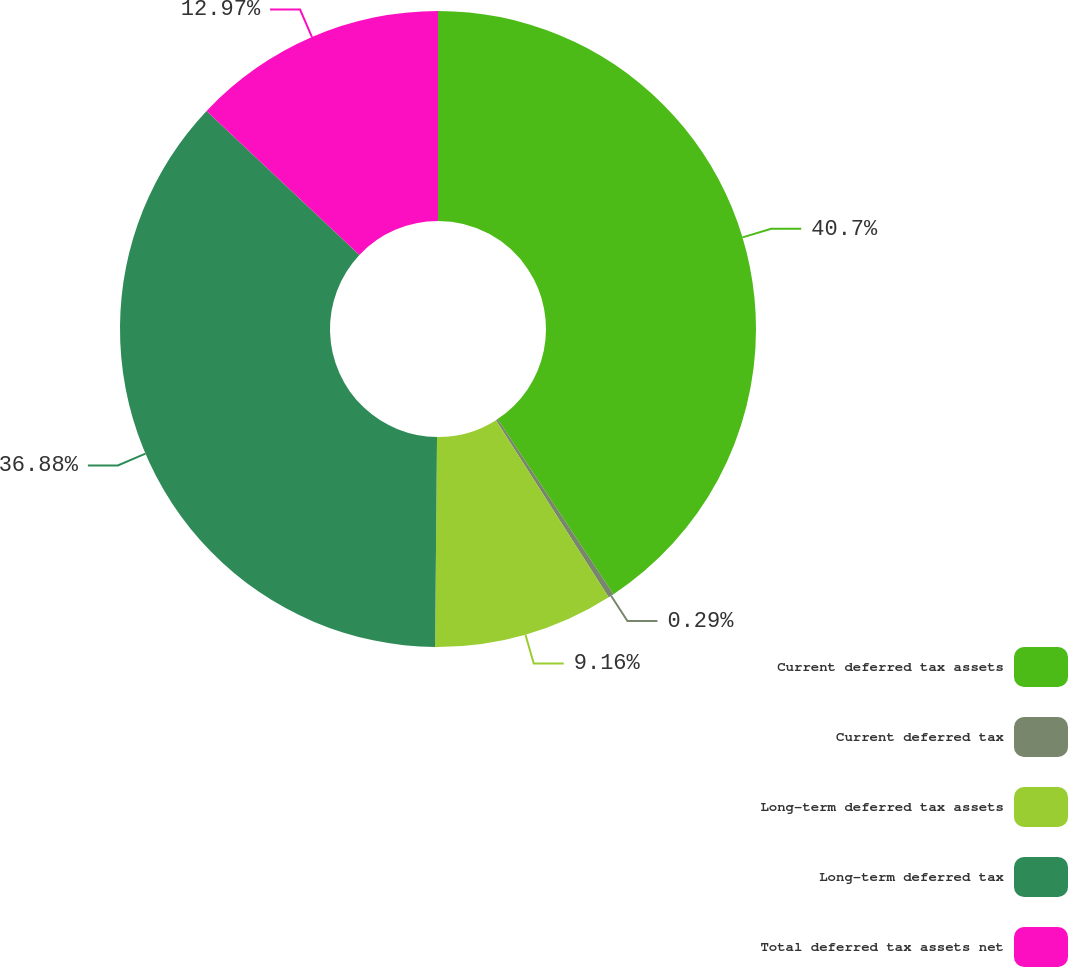Convert chart. <chart><loc_0><loc_0><loc_500><loc_500><pie_chart><fcel>Current deferred tax assets<fcel>Current deferred tax<fcel>Long-term deferred tax assets<fcel>Long-term deferred tax<fcel>Total deferred tax assets net<nl><fcel>40.69%<fcel>0.29%<fcel>9.16%<fcel>36.88%<fcel>12.97%<nl></chart> 